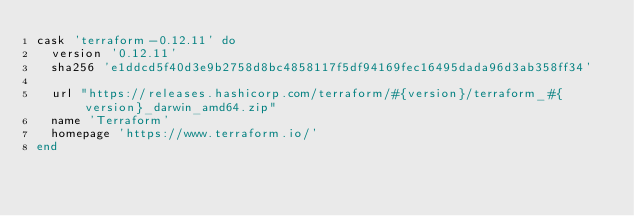<code> <loc_0><loc_0><loc_500><loc_500><_Ruby_>cask 'terraform-0.12.11' do
  version '0.12.11'
  sha256 'e1ddcd5f40d3e9b2758d8bc4858117f5df94169fec16495dada96d3ab358ff34'

  url "https://releases.hashicorp.com/terraform/#{version}/terraform_#{version}_darwin_amd64.zip"
  name 'Terraform'
  homepage 'https://www.terraform.io/'
end
</code> 